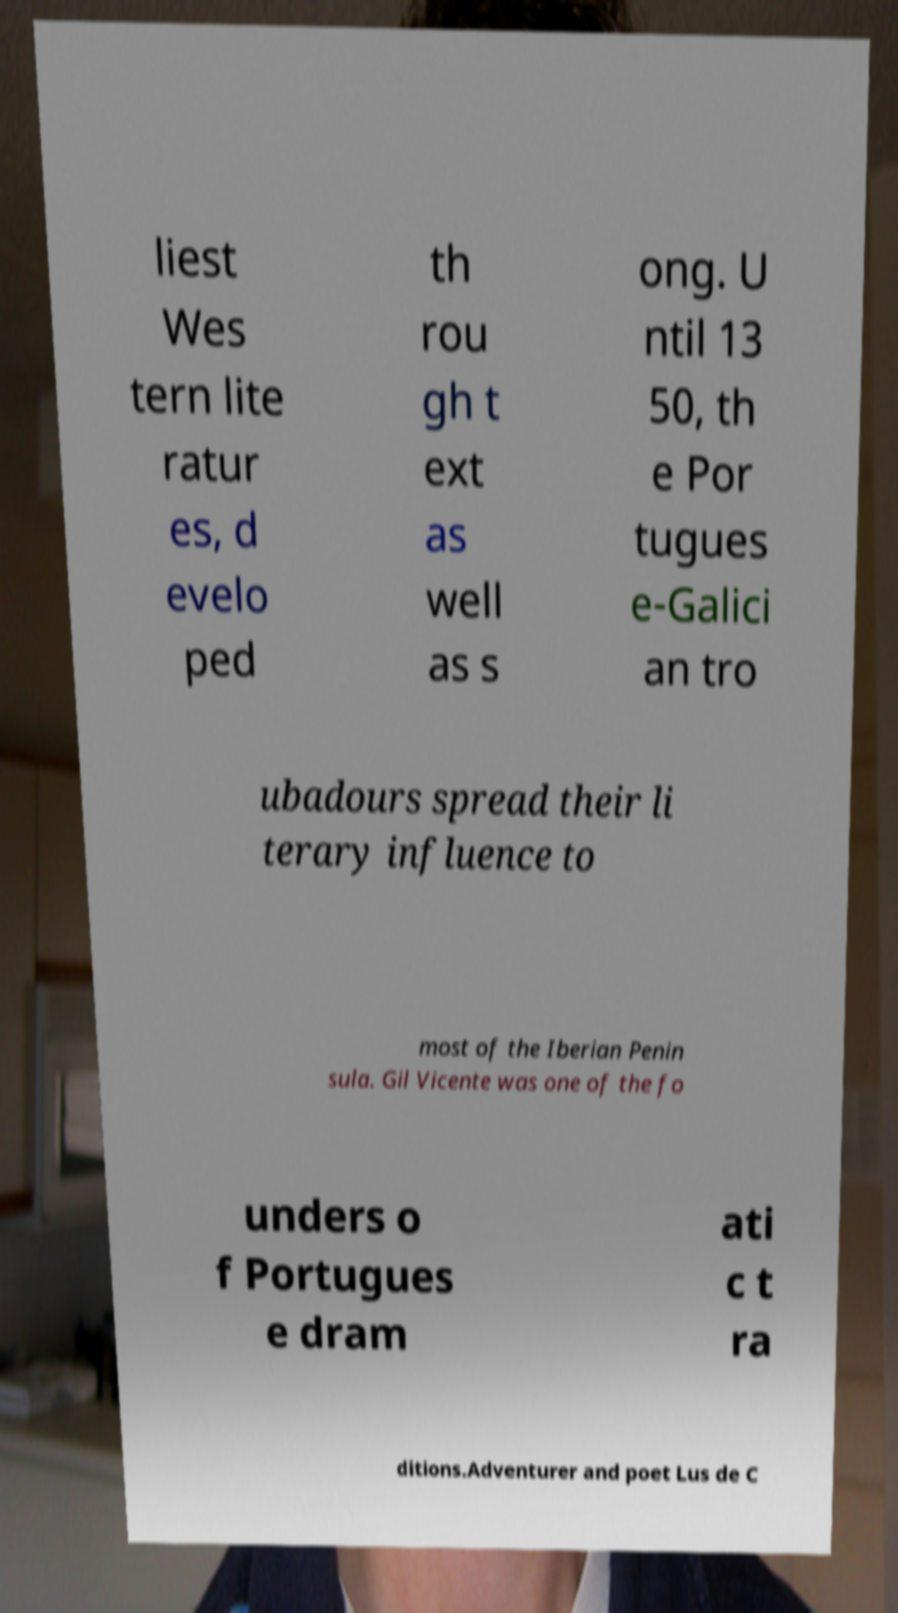Could you assist in decoding the text presented in this image and type it out clearly? liest Wes tern lite ratur es, d evelo ped th rou gh t ext as well as s ong. U ntil 13 50, th e Por tugues e-Galici an tro ubadours spread their li terary influence to most of the Iberian Penin sula. Gil Vicente was one of the fo unders o f Portugues e dram ati c t ra ditions.Adventurer and poet Lus de C 